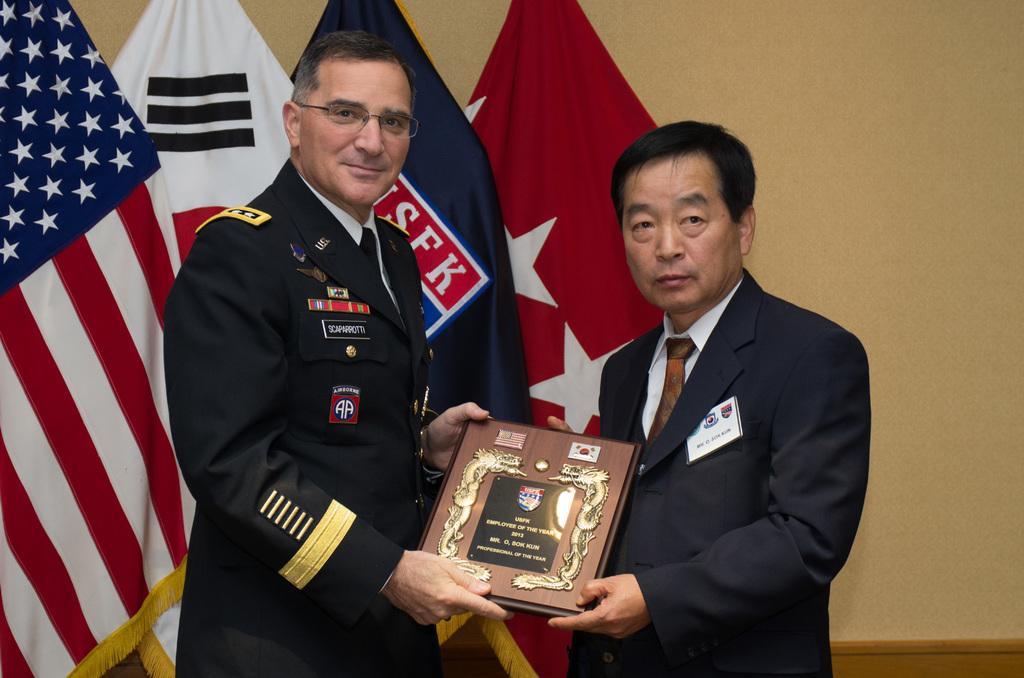Can you describe this image briefly? In this image, we can see two persons wearing clothes and holding a memorandum with their hands. There are flags in front of the wall. 